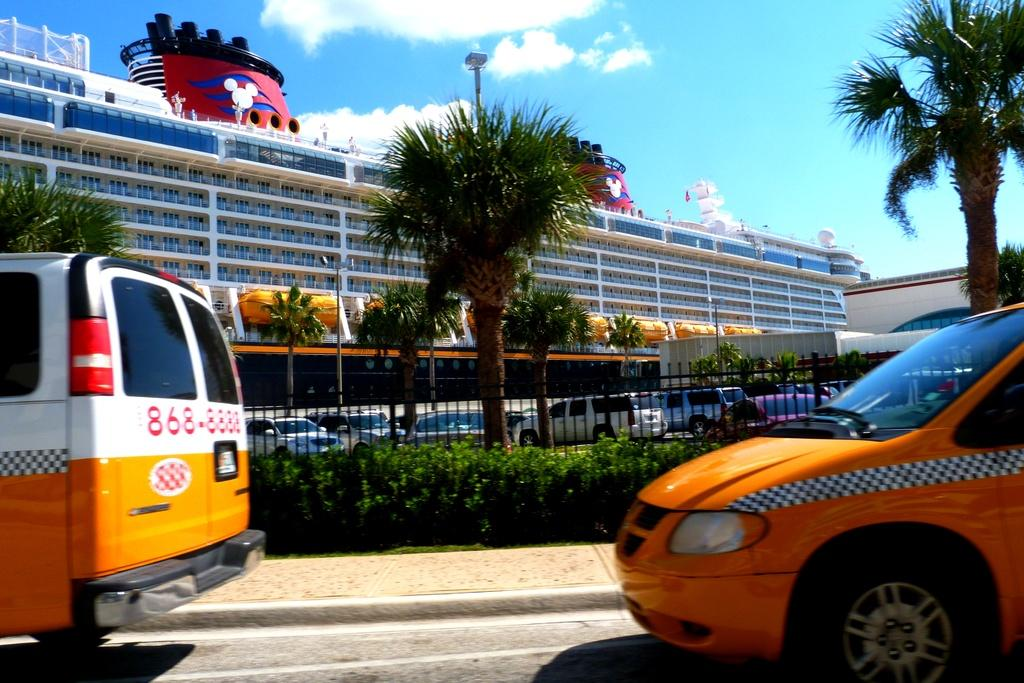<image>
Share a concise interpretation of the image provided. Two taxi vans in front of a cruise ship with one having a phone number 868-8888. 